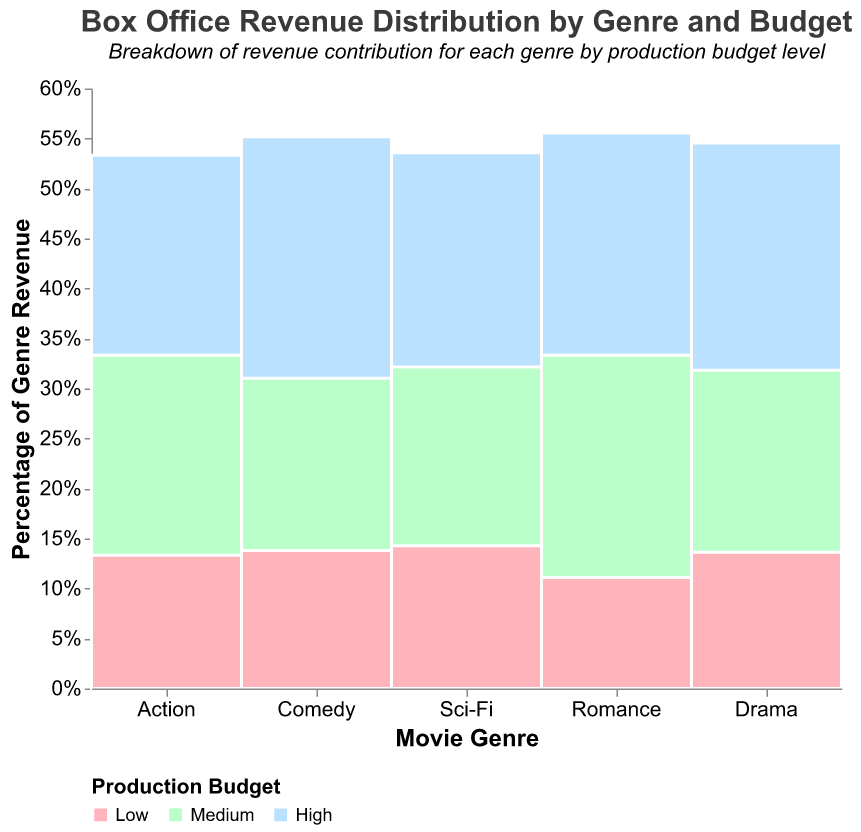What is the title of the figure? The title is located at the top of the figure and is clearly labeled to explain what the plot represents.
Answer: Box Office Revenue Distribution by Genre and Budget Which genre contributes the highest revenue with a high production budget? Look at the sections of the mosaic plot with a "High" production budget and check their height for each genre. The highest one will be the one which has the largest vertical span.
Answer: Sci-Fi What percentage of the total revenue in the Comedy genre is contributed by medium-budget productions? Find the Comedy genre in the plot, then locate the medium-budget section within it and check its percentage from the y-axis labels or the tool-tip.
Answer: 45% Does the Drama genre have equal revenue contributions from high and low-budget productions? Find the Drama genre in the plot and compare the heights of the high and low-budget sections. If the heights are the same, then their revenue contributions are equal, otherwise not.
Answer: No Compare the revenue contributions of high-budget Action movies to high-budget Romance movies. Which is higher? Identify the high-budget sections for both Action and Romance genres and compare their vertical spans. The one with a larger span has a higher revenue contribution.
Answer: Action Which genre has the lowest revenue from low-budget productions? Look at all the low-budget sections in the plot and find the one with the smallest vertical span. This will indicate the genre with the lowest revenue from low-budget productions.
Answer: Romance Is the revenue from high-budget Comedy movies greater than medium-budget Sci-Fi movies? Compare the vertical spans of the high-budget section in Comedy genre and the medium-budget section in Sci-Fi genre. The taller one indicates the greater revenue.
Answer: No How many distinct production budget levels are shown in the figure? Count the unique labels in the production budget legend showcased by colors.
Answer: 3 What is the sum of the revenues for low-budget movies in the Action genre? Identify the low-budget section in the Action genre and use the tool-tip or values for revenue. Sum them up if needed.
Answer: $300,000,000 Which budget level in the Drama genre contributes the least to its total revenue? Look at the Drama genre, identify the smallest section by height, indicating the least contribution.
Answer: Low 